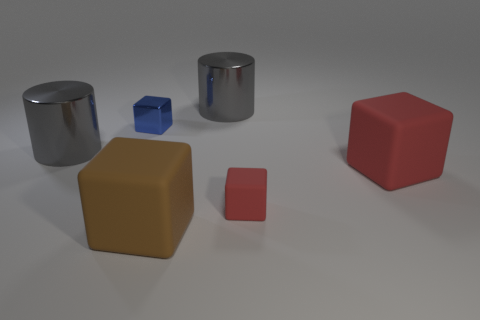Add 1 tiny cyan shiny things. How many objects exist? 7 Subtract all blocks. How many objects are left? 2 Subtract all metallic cylinders. Subtract all large gray metallic objects. How many objects are left? 2 Add 2 brown matte blocks. How many brown matte blocks are left? 3 Add 6 large gray cylinders. How many large gray cylinders exist? 8 Subtract 0 green spheres. How many objects are left? 6 